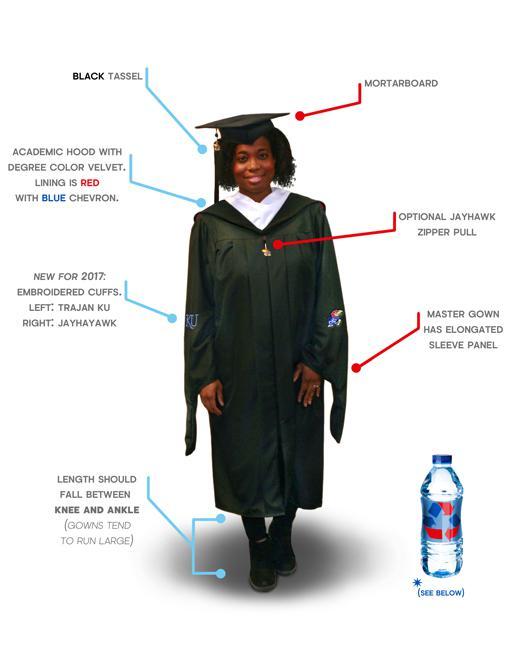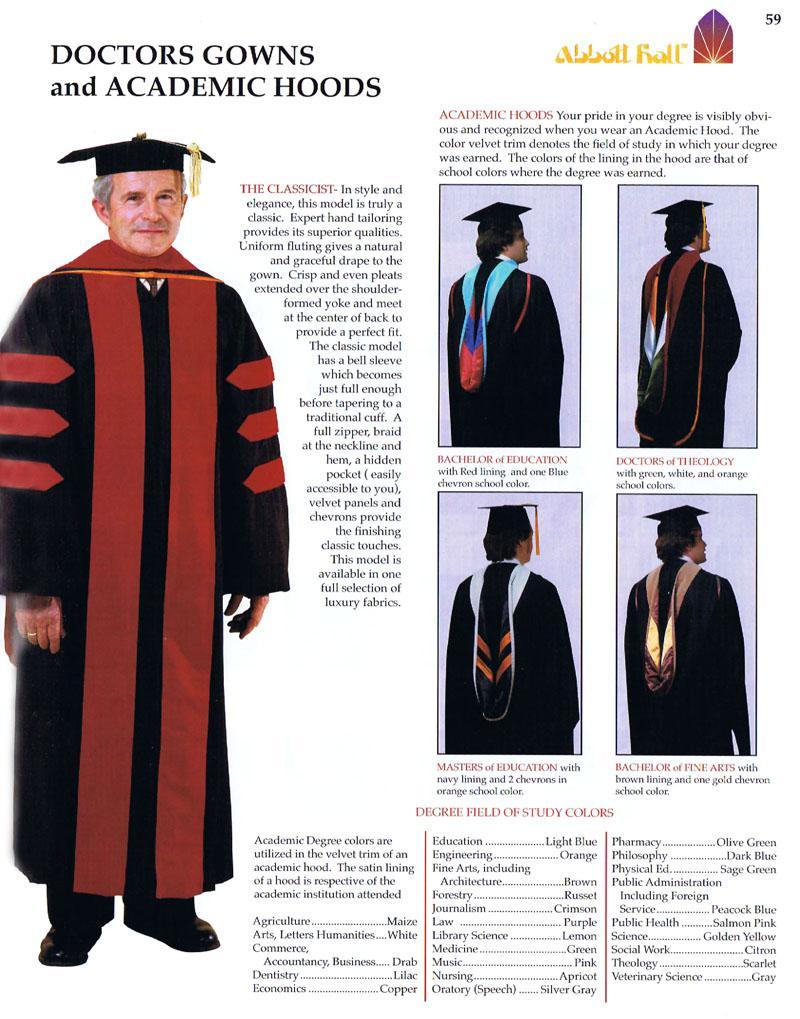The first image is the image on the left, the second image is the image on the right. Given the left and right images, does the statement "In one image, the gown is accessorized with a red scarf worn around the neck, hanging open at the waist." hold true? Answer yes or no. No. 